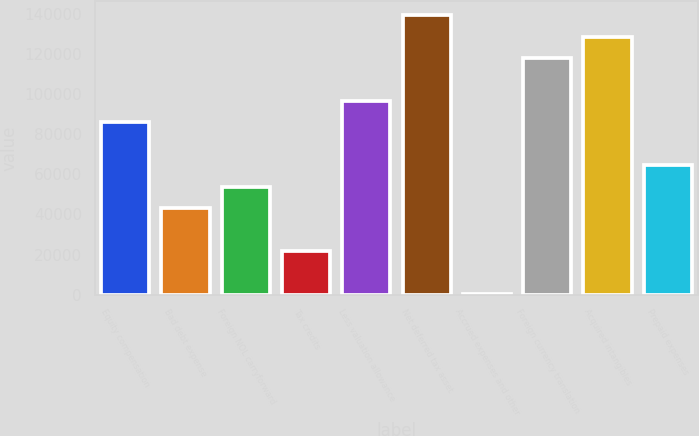Convert chart. <chart><loc_0><loc_0><loc_500><loc_500><bar_chart><fcel>Equity compensation<fcel>Bad debt expense<fcel>Foreign NOL carryforward<fcel>Tax credits<fcel>Less valuation allowance<fcel>Net deferred tax asset<fcel>Accrued expenses and other<fcel>Foreign currency translation<fcel>Acquired intangibles<fcel>Prepaid expenses<nl><fcel>85969.4<fcel>43232.2<fcel>53916.5<fcel>21863.6<fcel>96653.7<fcel>139391<fcel>495<fcel>118022<fcel>128707<fcel>64600.8<nl></chart> 